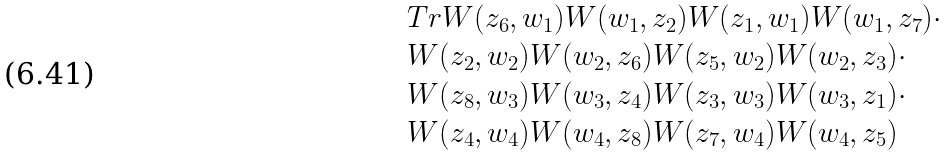Convert formula to latex. <formula><loc_0><loc_0><loc_500><loc_500>\begin{array} { r l } & T r W ( z _ { 6 } , w _ { 1 } ) W ( w _ { 1 } , z _ { 2 } ) W ( z _ { 1 } , w _ { 1 } ) W ( w _ { 1 } , z _ { 7 } ) \cdot \\ & W ( z _ { 2 } , w _ { 2 } ) W ( w _ { 2 } , z _ { 6 } ) W ( z _ { 5 } , w _ { 2 } ) W ( w _ { 2 } , z _ { 3 } ) \cdot \\ & W ( z _ { 8 } , w _ { 3 } ) W ( w _ { 3 } , z _ { 4 } ) W ( z _ { 3 } , w _ { 3 } ) W ( w _ { 3 } , z _ { 1 } ) \cdot \\ & W ( z _ { 4 } , w _ { 4 } ) W ( w _ { 4 } , z _ { 8 } ) W ( z _ { 7 } , w _ { 4 } ) W ( w _ { 4 } , z _ { 5 } ) \end{array}</formula> 